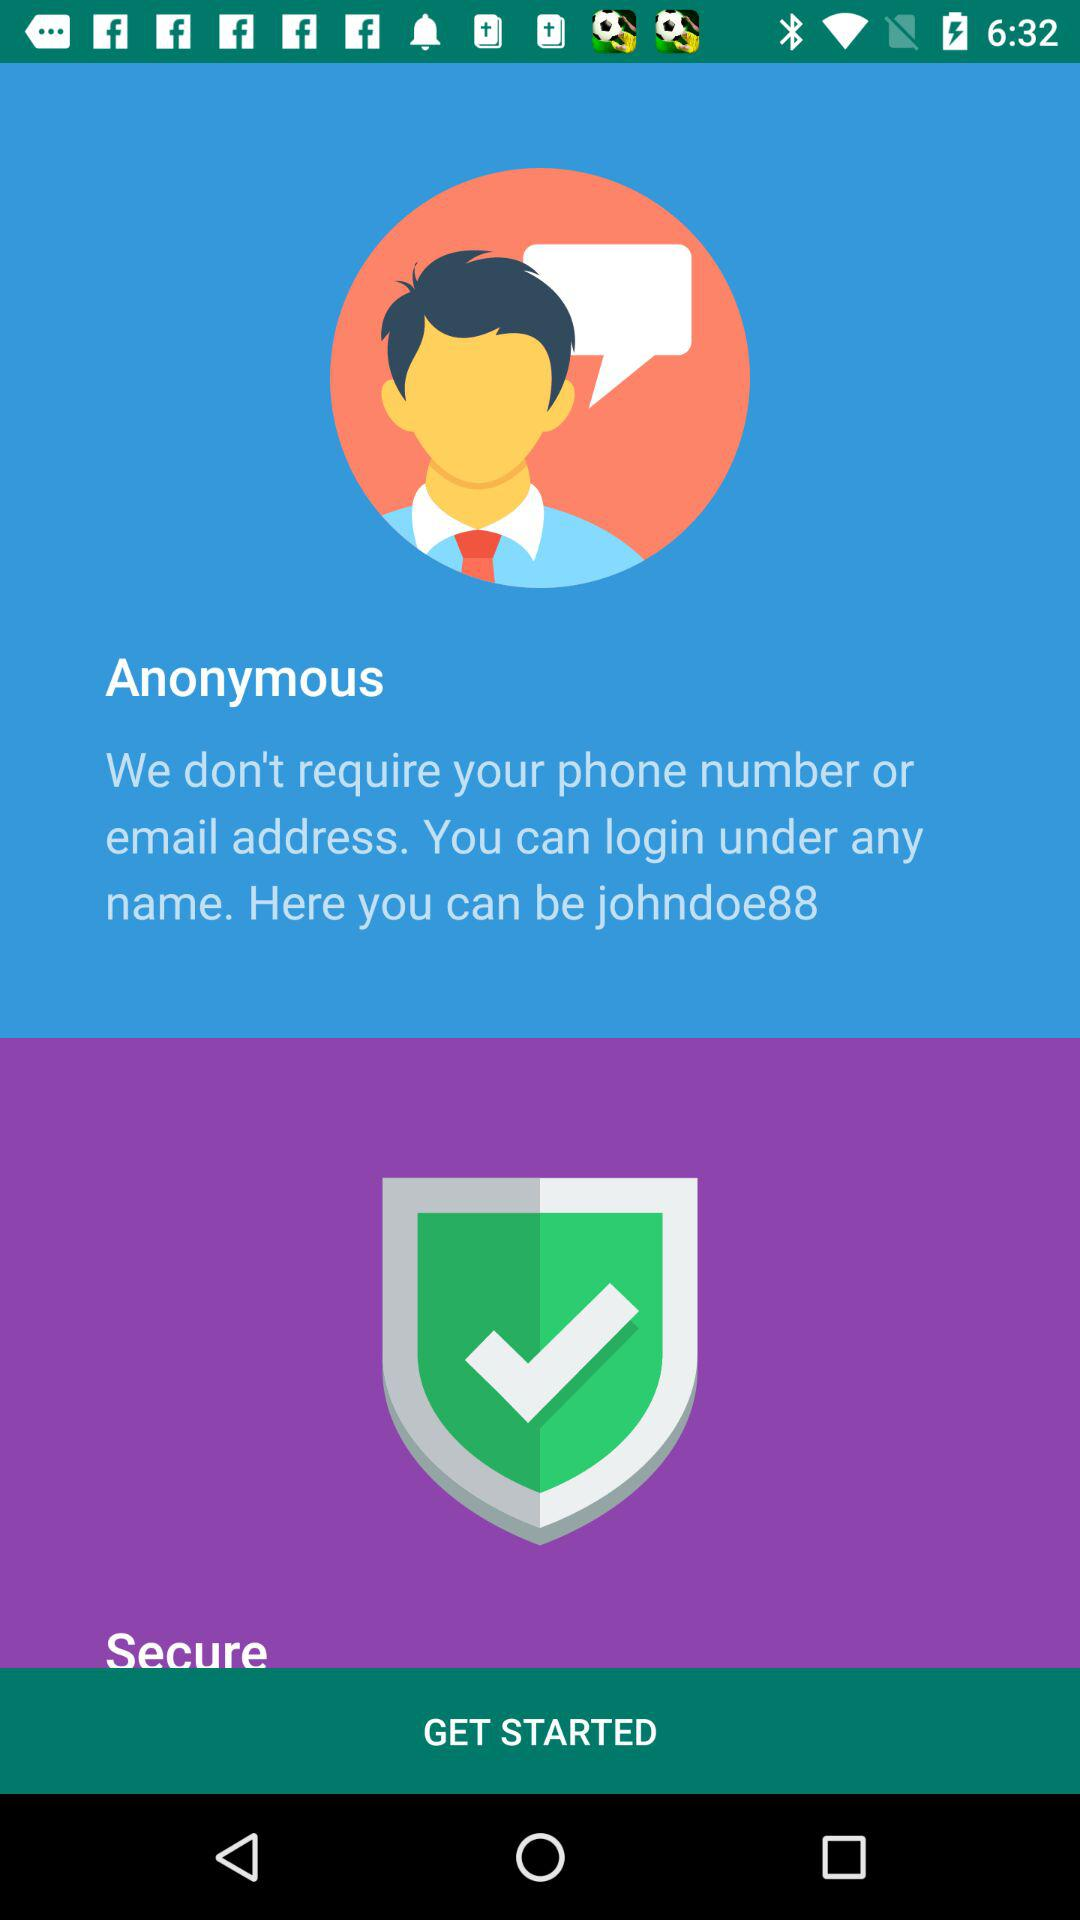What username can be used? The username "johndoe88" can be used. 